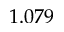Convert formula to latex. <formula><loc_0><loc_0><loc_500><loc_500>1 . 0 7 9</formula> 